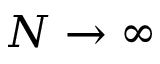Convert formula to latex. <formula><loc_0><loc_0><loc_500><loc_500>N \rightarrow \infty</formula> 